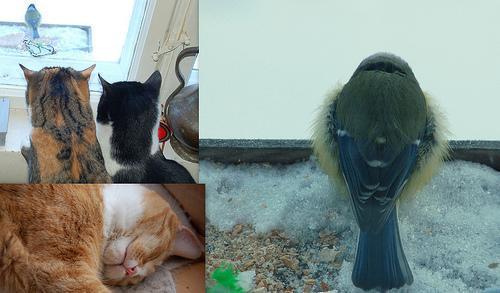How many birds are in the pictures?
Give a very brief answer. 1. 